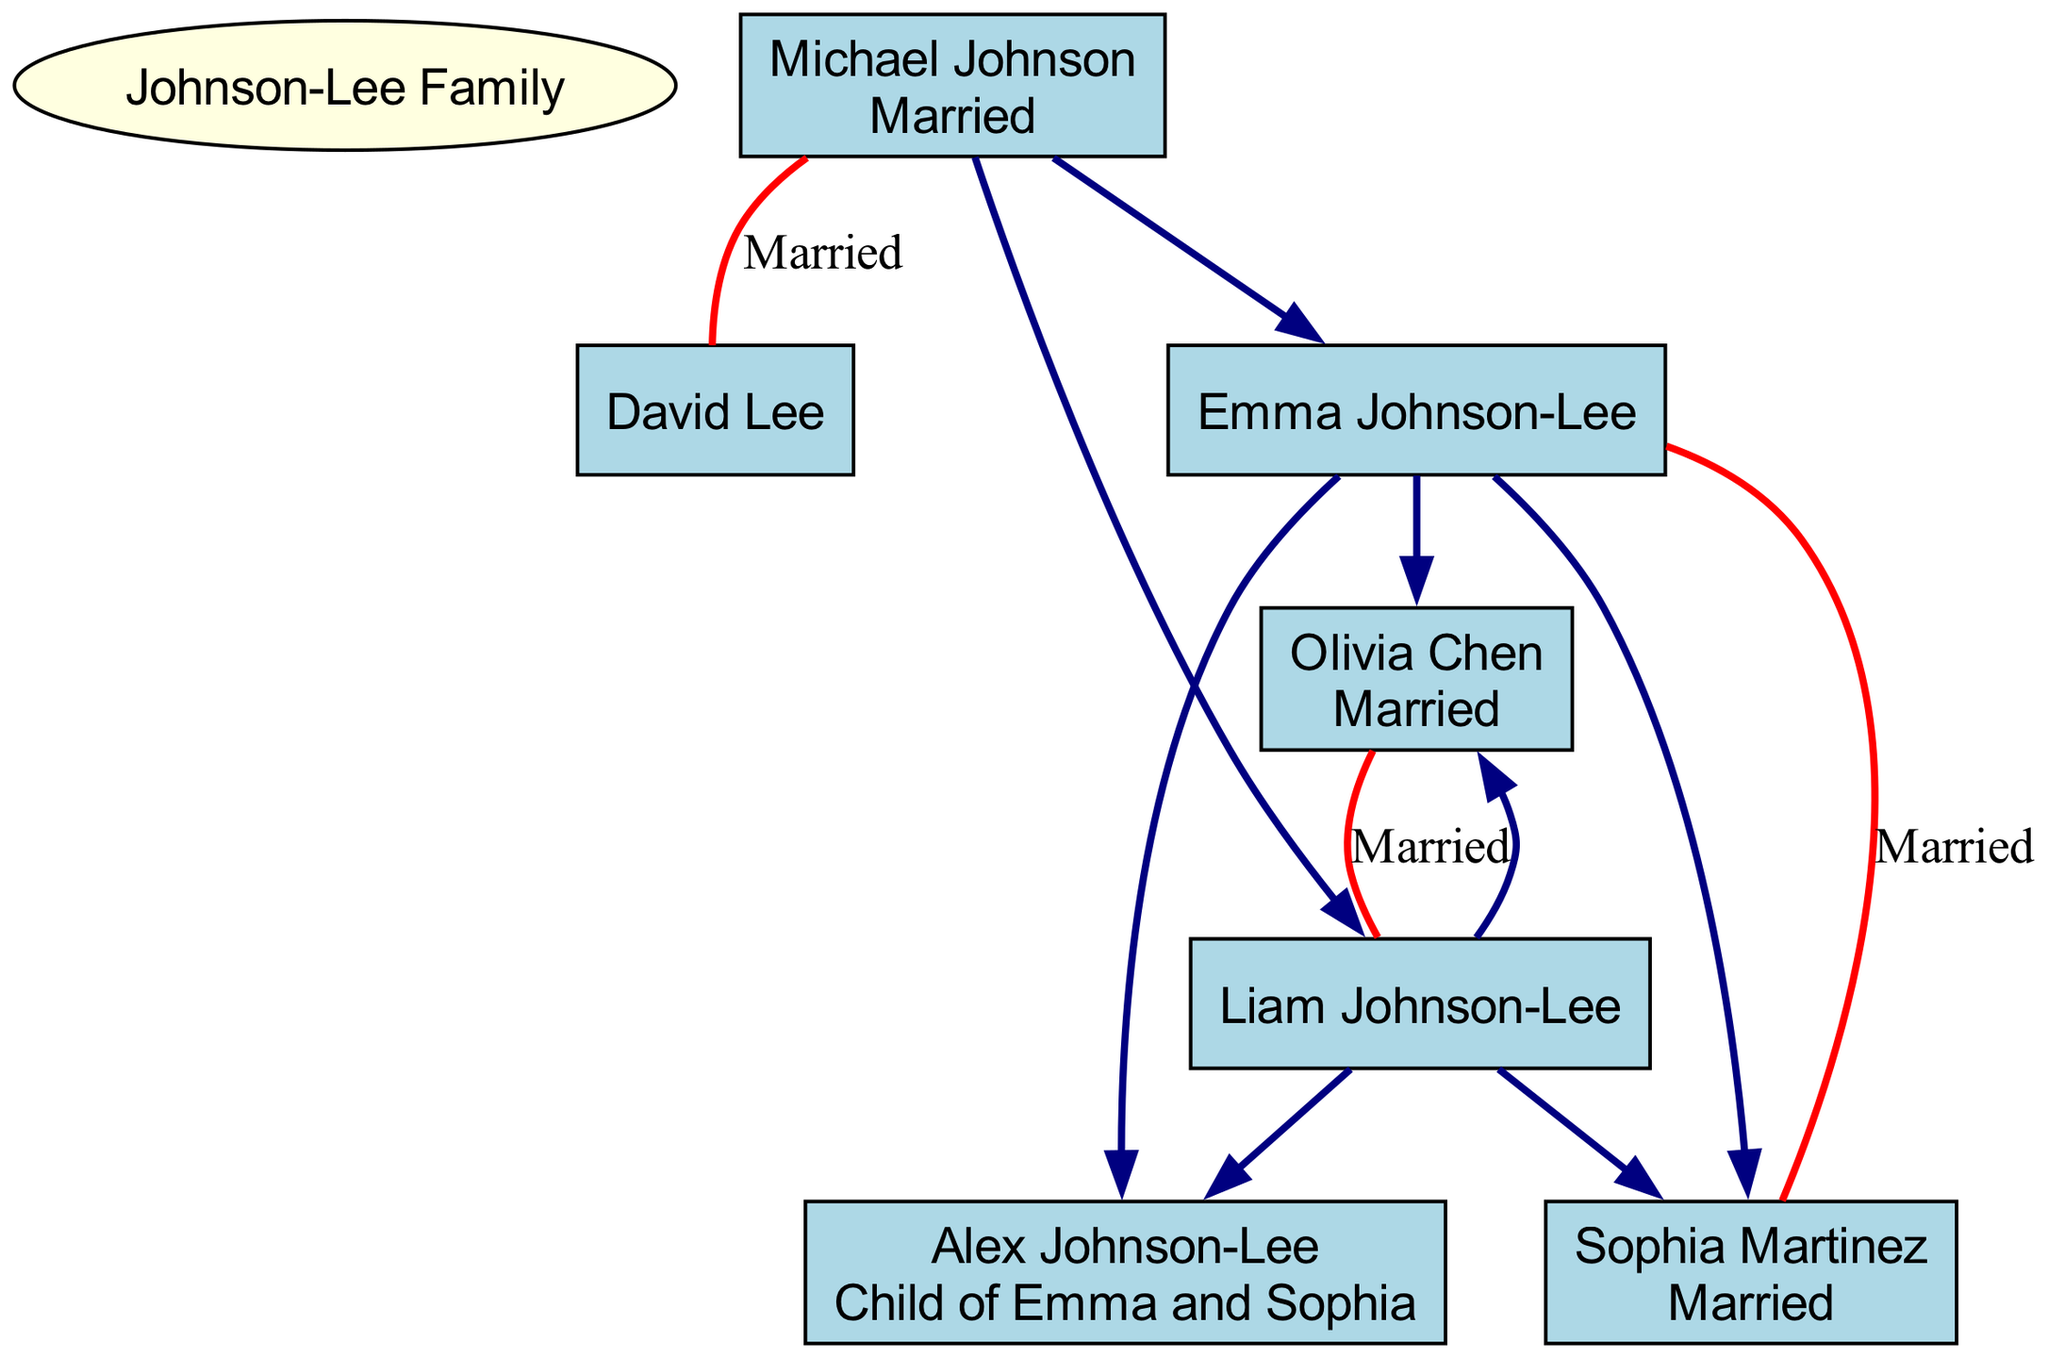What is the name of the root family? The root family is indicated at the top of the diagram and is labeled as "Johnson-Lee Family."
Answer: Johnson-Lee Family How many children are there in the second generation? The second generation has two children listed: Emma Johnson-Lee and Liam Johnson-Lee. Therefore, we count these two to answer the question.
Answer: 2 What is the relationship of Liam Johnson-Lee to Michael Johnson? To determine this relationship, we trace back from Liam Johnson-Lee to his parent Michael Johnson, who is listed as his father.
Answer: Father Who is Sophia Martinez's partner? Sophia Martinez is connected through a labeled relationship ("Married") to Emma Johnson-Lee, indicating their partnership in the diagram.
Answer: Emma Johnson-Lee What type of relationship do Michael Johnson and David Lee share? The label associated with their connection specifies that they are "Married," indicating their relationship status in the diagram.
Answer: Married How many grandchildren does Michael Johnson have? Michael Johnson has two grandchildren, Alex Johnson-Lee and another unidentified grandchild of Liam Johnson-Lee, who is implicitly indicated, making it a total of two.
Answer: 2 What is the relationship of Alex Johnson-Lee to Sophia Martinez? Alex Johnson-Lee is the child of Emma Johnson-Lee and Sophia Martinez, making Sophia his legal mother by marriage, hence, Alex's relationship to her is "Child."
Answer: Child Which family member is adopted? The diagram explicitly identifies Emma Johnson-Lee as the adopted child of Michael Johnson and David Lee.
Answer: Emma Johnson-Lee What color is used for the family members' nodes? The nodes representing the family members are given a specific color attribute, as defined in the diagram code, which is light blue.
Answer: Light blue 